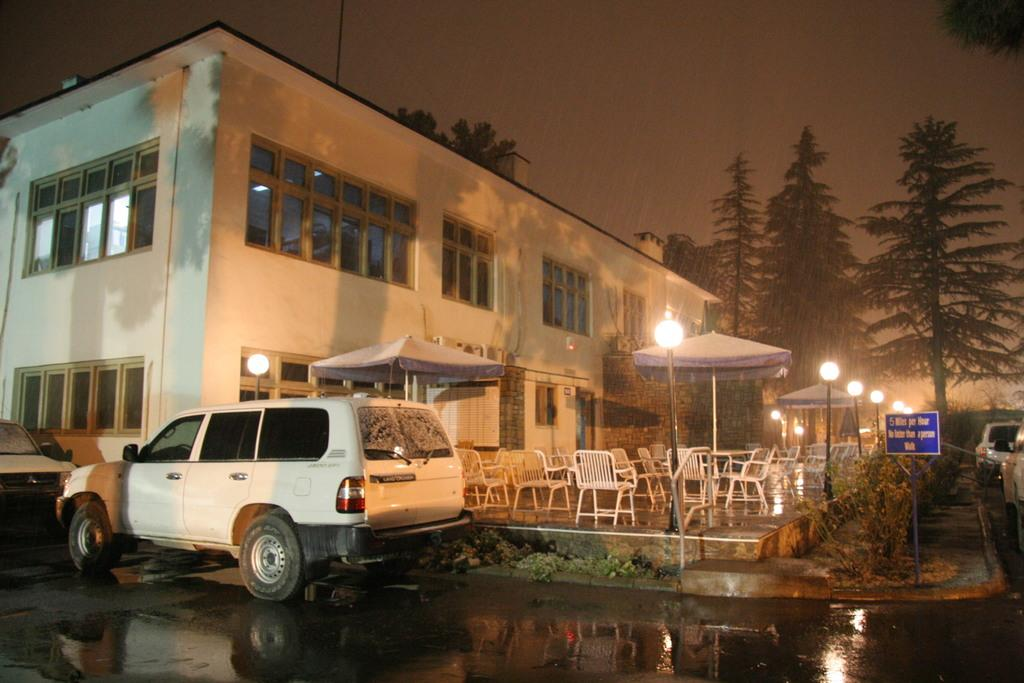What can be seen on the road in the image? There are vehicles on the road in the image. What type of furniture is present in the image? There are chairs in the image. What temporary shelters can be seen in the image? There are tents in the image. What structures provide illumination in the image? There are light poles in the image. What type of signage is present in the image? There are boards in the image. What type of vegetation is present in the image? There are trees and plants in the image. What type of structure is present in the image? There is a building in the image. What is visible at the top of the image? The sky is visible at the top of the image. How many horns can be seen on the rod in the image? There is no rod or horns present in the image. What type of fan is visible in the image? There is no fan present in the image. 